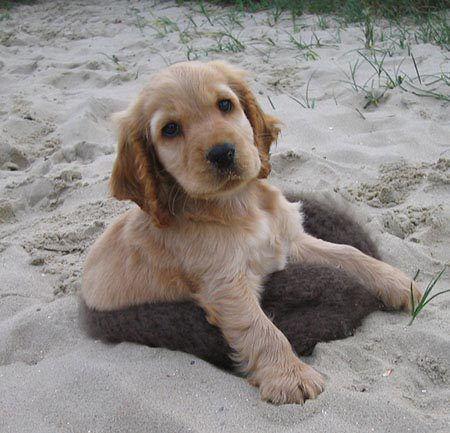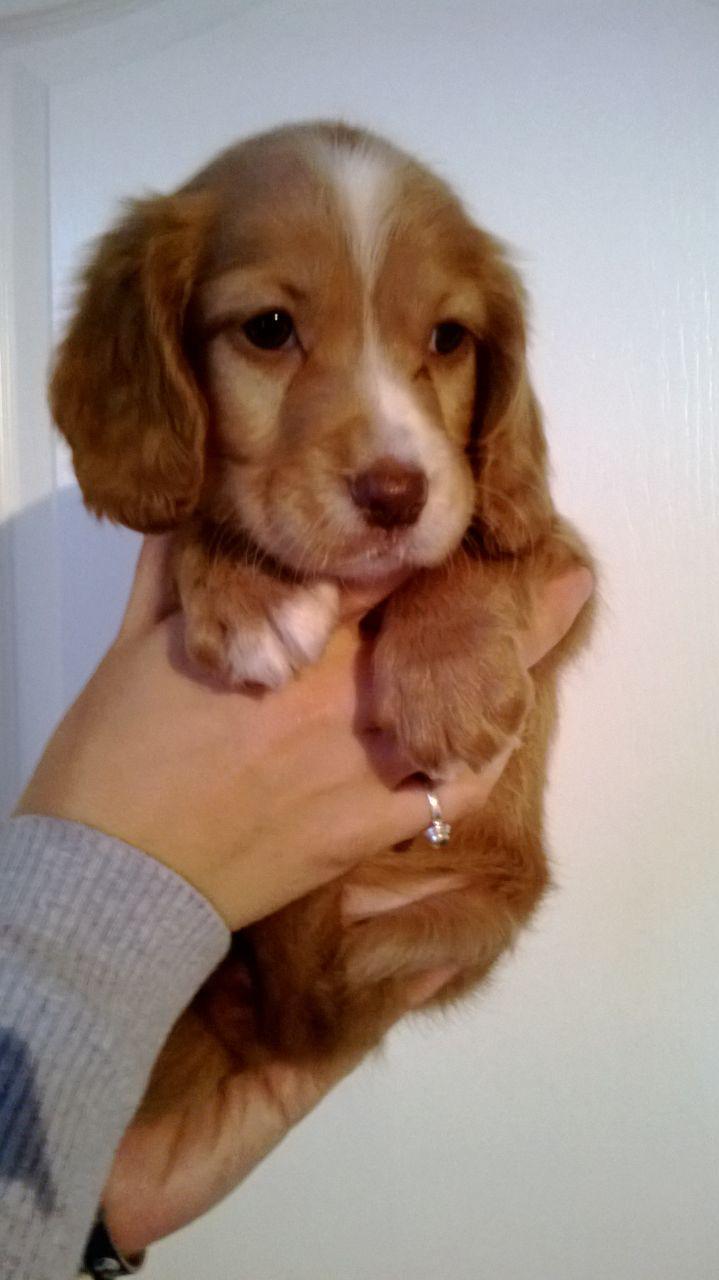The first image is the image on the left, the second image is the image on the right. Given the left and right images, does the statement "A dog is sitting with a dog of another species in the image on the left." hold true? Answer yes or no. No. 